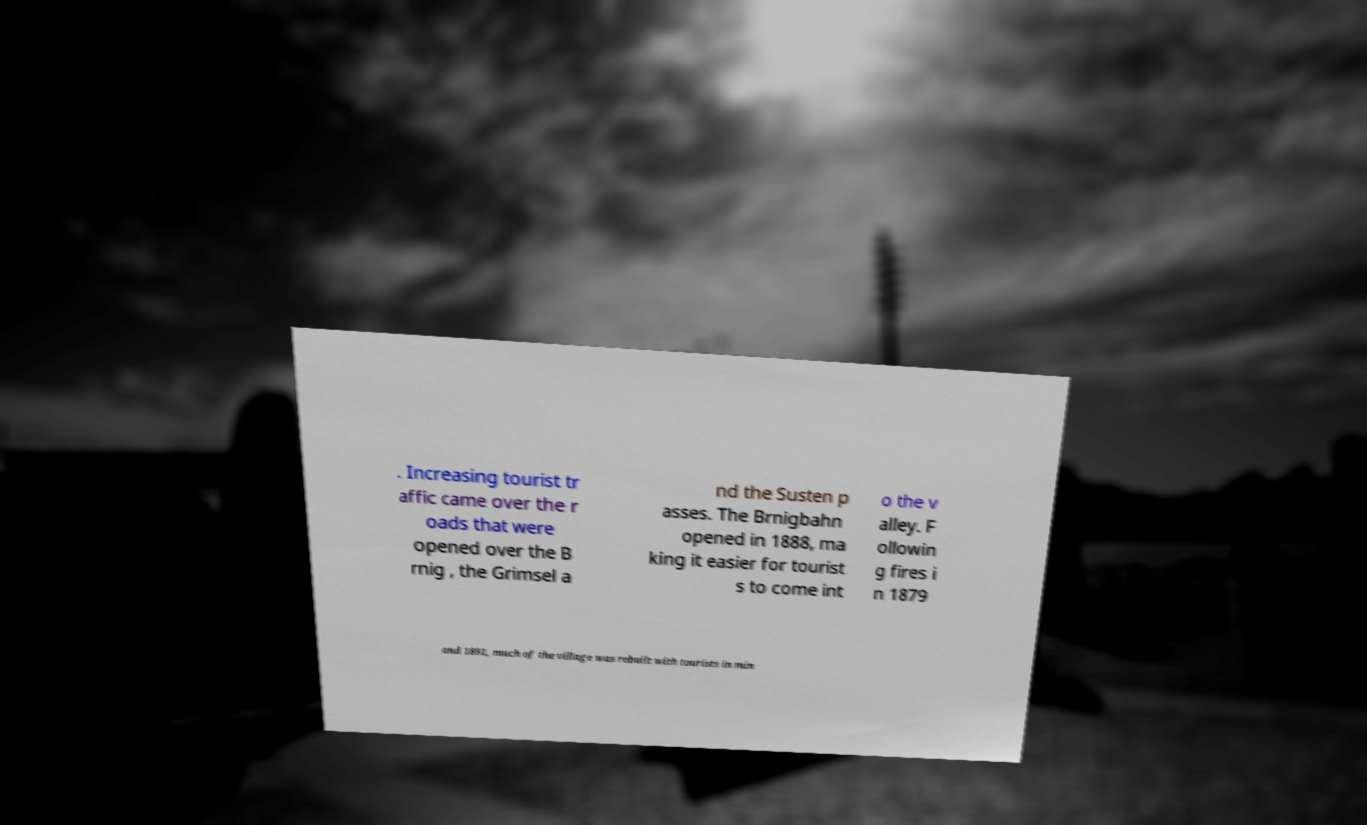Please read and relay the text visible in this image. What does it say? . Increasing tourist tr affic came over the r oads that were opened over the B rnig , the Grimsel a nd the Susten p asses. The Brnigbahn opened in 1888, ma king it easier for tourist s to come int o the v alley. F ollowin g fires i n 1879 and 1891, much of the village was rebuilt with tourists in min 